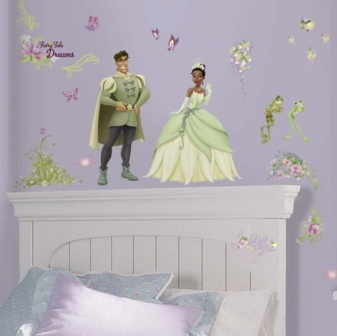What theme does this bedroom decor suggest? The bedroom decor suggests a fairytale or fantasy theme. The presence of the prince and princess, along with the frog and numerous whimsical butterflies and flowers, indicates a world of imagination and storybook charm, inviting thoughts of magical adventures and enchanting tales. 